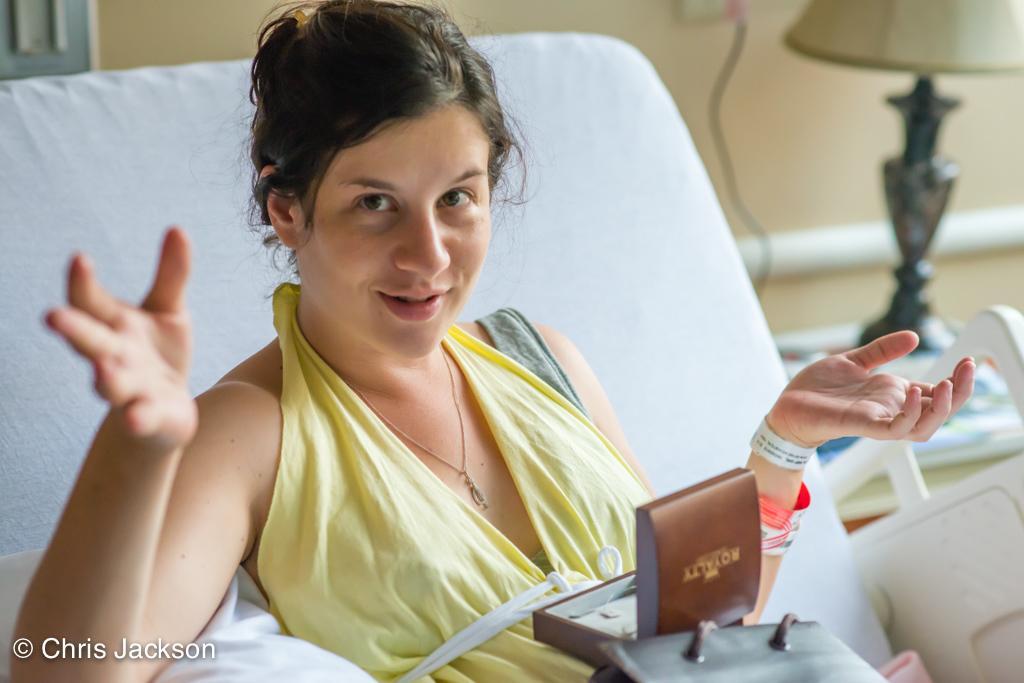Could you give a brief overview of what you see in this image? In this image we can see there is a lady lay on the bed and looking into the camera and there are few objects placed on her stomach, beside the bed there is a lamp on the table. 